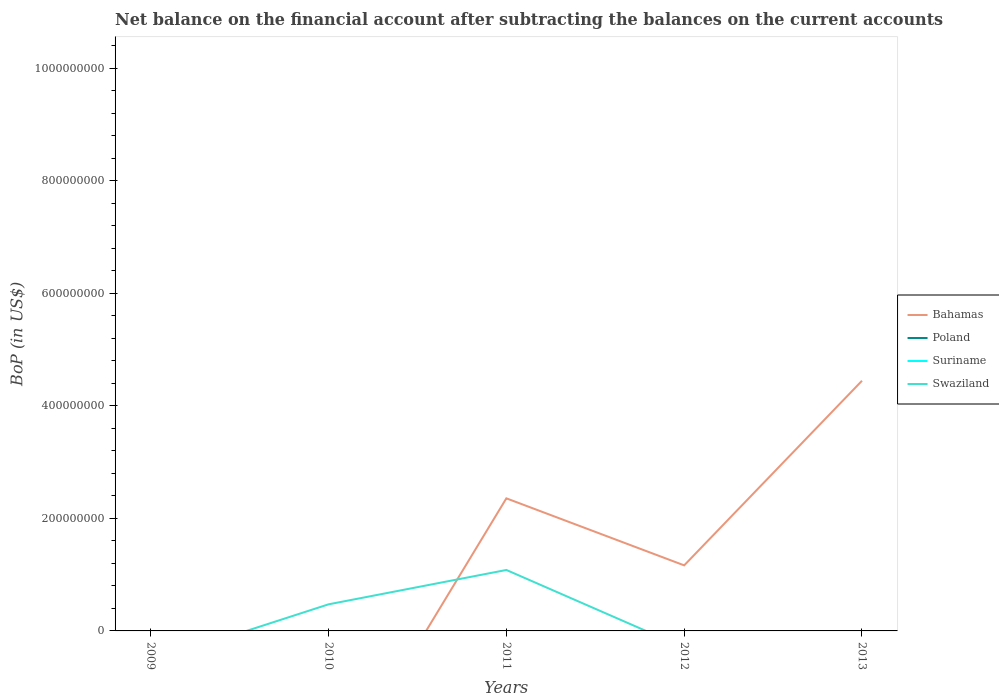Does the line corresponding to Swaziland intersect with the line corresponding to Suriname?
Provide a succinct answer. Yes. What is the total Balance of Payments in Bahamas in the graph?
Your response must be concise. 1.19e+08. What is the difference between the highest and the second highest Balance of Payments in Bahamas?
Your response must be concise. 4.44e+08. What is the difference between two consecutive major ticks on the Y-axis?
Make the answer very short. 2.00e+08. Does the graph contain any zero values?
Ensure brevity in your answer.  Yes. How many legend labels are there?
Provide a short and direct response. 4. What is the title of the graph?
Ensure brevity in your answer.  Net balance on the financial account after subtracting the balances on the current accounts. What is the label or title of the Y-axis?
Ensure brevity in your answer.  BoP (in US$). What is the BoP (in US$) of Bahamas in 2009?
Your answer should be very brief. 0. What is the BoP (in US$) of Swaziland in 2009?
Make the answer very short. 0. What is the BoP (in US$) of Bahamas in 2010?
Offer a terse response. 0. What is the BoP (in US$) of Poland in 2010?
Your answer should be very brief. 0. What is the BoP (in US$) in Suriname in 2010?
Make the answer very short. 0. What is the BoP (in US$) in Swaziland in 2010?
Your answer should be very brief. 4.73e+07. What is the BoP (in US$) in Bahamas in 2011?
Provide a short and direct response. 2.36e+08. What is the BoP (in US$) of Suriname in 2011?
Offer a very short reply. 0. What is the BoP (in US$) in Swaziland in 2011?
Your answer should be very brief. 1.08e+08. What is the BoP (in US$) of Bahamas in 2012?
Offer a very short reply. 1.16e+08. What is the BoP (in US$) of Bahamas in 2013?
Give a very brief answer. 4.44e+08. What is the BoP (in US$) of Poland in 2013?
Your response must be concise. 0. What is the BoP (in US$) in Swaziland in 2013?
Offer a terse response. 0. Across all years, what is the maximum BoP (in US$) of Bahamas?
Offer a very short reply. 4.44e+08. Across all years, what is the maximum BoP (in US$) of Swaziland?
Your answer should be compact. 1.08e+08. Across all years, what is the minimum BoP (in US$) of Bahamas?
Keep it short and to the point. 0. What is the total BoP (in US$) of Bahamas in the graph?
Make the answer very short. 7.97e+08. What is the total BoP (in US$) of Suriname in the graph?
Your answer should be compact. 0. What is the total BoP (in US$) in Swaziland in the graph?
Your answer should be compact. 1.56e+08. What is the difference between the BoP (in US$) of Swaziland in 2010 and that in 2011?
Provide a short and direct response. -6.11e+07. What is the difference between the BoP (in US$) in Bahamas in 2011 and that in 2012?
Keep it short and to the point. 1.19e+08. What is the difference between the BoP (in US$) in Bahamas in 2011 and that in 2013?
Provide a short and direct response. -2.09e+08. What is the difference between the BoP (in US$) of Bahamas in 2012 and that in 2013?
Provide a short and direct response. -3.28e+08. What is the average BoP (in US$) of Bahamas per year?
Keep it short and to the point. 1.59e+08. What is the average BoP (in US$) of Poland per year?
Offer a terse response. 0. What is the average BoP (in US$) in Suriname per year?
Offer a very short reply. 0. What is the average BoP (in US$) of Swaziland per year?
Provide a short and direct response. 3.11e+07. In the year 2011, what is the difference between the BoP (in US$) of Bahamas and BoP (in US$) of Swaziland?
Ensure brevity in your answer.  1.27e+08. What is the ratio of the BoP (in US$) of Swaziland in 2010 to that in 2011?
Give a very brief answer. 0.44. What is the ratio of the BoP (in US$) in Bahamas in 2011 to that in 2012?
Your answer should be very brief. 2.02. What is the ratio of the BoP (in US$) in Bahamas in 2011 to that in 2013?
Make the answer very short. 0.53. What is the ratio of the BoP (in US$) of Bahamas in 2012 to that in 2013?
Ensure brevity in your answer.  0.26. What is the difference between the highest and the second highest BoP (in US$) in Bahamas?
Offer a terse response. 2.09e+08. What is the difference between the highest and the lowest BoP (in US$) in Bahamas?
Provide a succinct answer. 4.44e+08. What is the difference between the highest and the lowest BoP (in US$) of Swaziland?
Your answer should be very brief. 1.08e+08. 